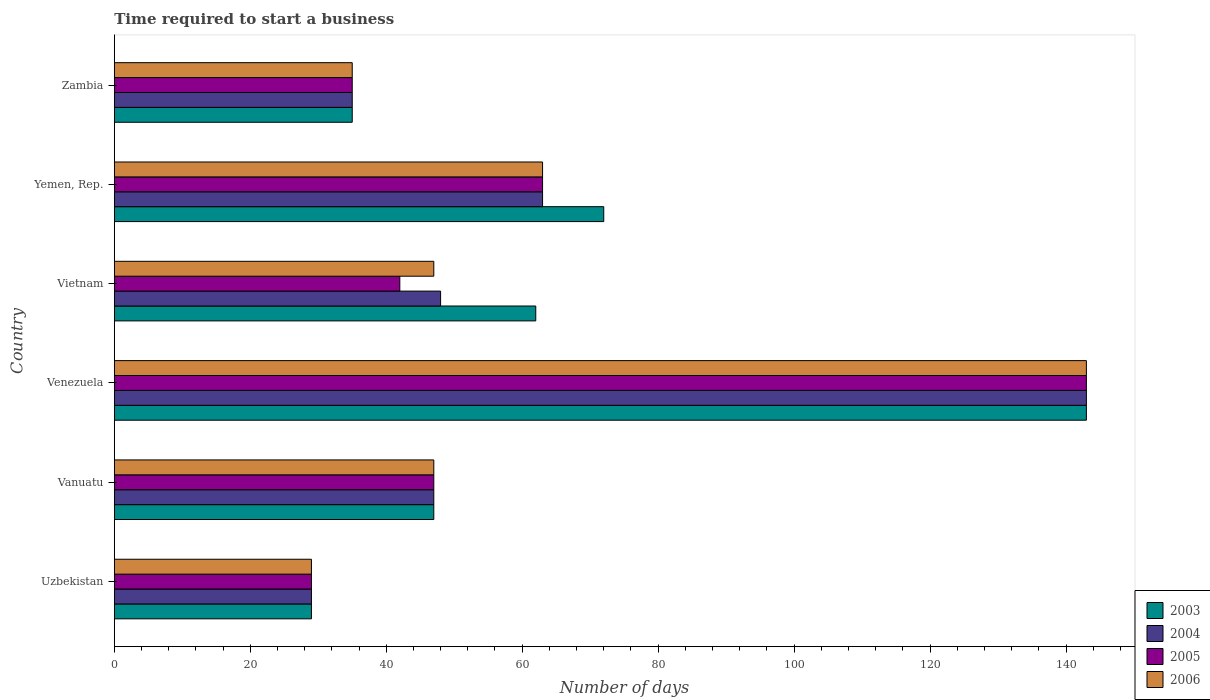How many groups of bars are there?
Make the answer very short. 6. Are the number of bars per tick equal to the number of legend labels?
Give a very brief answer. Yes. Are the number of bars on each tick of the Y-axis equal?
Your answer should be compact. Yes. What is the label of the 5th group of bars from the top?
Offer a terse response. Vanuatu. In how many cases, is the number of bars for a given country not equal to the number of legend labels?
Your answer should be compact. 0. What is the number of days required to start a business in 2004 in Uzbekistan?
Your answer should be very brief. 29. Across all countries, what is the maximum number of days required to start a business in 2004?
Make the answer very short. 143. In which country was the number of days required to start a business in 2003 maximum?
Your answer should be very brief. Venezuela. In which country was the number of days required to start a business in 2003 minimum?
Your answer should be very brief. Uzbekistan. What is the total number of days required to start a business in 2004 in the graph?
Your answer should be very brief. 365. What is the difference between the number of days required to start a business in 2003 in Vanuatu and that in Zambia?
Your answer should be compact. 12. What is the difference between the number of days required to start a business in 2004 in Yemen, Rep. and the number of days required to start a business in 2005 in Venezuela?
Provide a succinct answer. -80. What is the average number of days required to start a business in 2005 per country?
Provide a succinct answer. 59.83. What is the difference between the number of days required to start a business in 2003 and number of days required to start a business in 2006 in Zambia?
Provide a succinct answer. 0. What is the ratio of the number of days required to start a business in 2004 in Uzbekistan to that in Vietnam?
Offer a very short reply. 0.6. Is the number of days required to start a business in 2004 in Venezuela less than that in Zambia?
Provide a succinct answer. No. What is the difference between the highest and the second highest number of days required to start a business in 2004?
Offer a very short reply. 80. What is the difference between the highest and the lowest number of days required to start a business in 2005?
Provide a succinct answer. 114. In how many countries, is the number of days required to start a business in 2004 greater than the average number of days required to start a business in 2004 taken over all countries?
Offer a terse response. 2. Is it the case that in every country, the sum of the number of days required to start a business in 2005 and number of days required to start a business in 2006 is greater than the sum of number of days required to start a business in 2004 and number of days required to start a business in 2003?
Provide a succinct answer. No. What does the 1st bar from the top in Vanuatu represents?
Ensure brevity in your answer.  2006. How many bars are there?
Your answer should be compact. 24. How many countries are there in the graph?
Your answer should be compact. 6. Are the values on the major ticks of X-axis written in scientific E-notation?
Your answer should be very brief. No. Does the graph contain grids?
Offer a terse response. No. What is the title of the graph?
Provide a succinct answer. Time required to start a business. What is the label or title of the X-axis?
Offer a terse response. Number of days. What is the label or title of the Y-axis?
Provide a short and direct response. Country. What is the Number of days in 2004 in Vanuatu?
Your response must be concise. 47. What is the Number of days in 2005 in Vanuatu?
Offer a very short reply. 47. What is the Number of days of 2003 in Venezuela?
Provide a succinct answer. 143. What is the Number of days of 2004 in Venezuela?
Make the answer very short. 143. What is the Number of days in 2005 in Venezuela?
Provide a short and direct response. 143. What is the Number of days of 2006 in Venezuela?
Your answer should be very brief. 143. What is the Number of days in 2003 in Vietnam?
Your response must be concise. 62. What is the Number of days of 2004 in Vietnam?
Ensure brevity in your answer.  48. What is the Number of days of 2005 in Vietnam?
Provide a succinct answer. 42. What is the Number of days in 2003 in Yemen, Rep.?
Ensure brevity in your answer.  72. What is the Number of days of 2004 in Yemen, Rep.?
Your response must be concise. 63. What is the Number of days in 2005 in Yemen, Rep.?
Your answer should be compact. 63. What is the Number of days in 2006 in Yemen, Rep.?
Offer a terse response. 63. What is the Number of days of 2004 in Zambia?
Offer a terse response. 35. Across all countries, what is the maximum Number of days of 2003?
Your answer should be compact. 143. Across all countries, what is the maximum Number of days in 2004?
Your response must be concise. 143. Across all countries, what is the maximum Number of days of 2005?
Provide a short and direct response. 143. Across all countries, what is the maximum Number of days of 2006?
Ensure brevity in your answer.  143. Across all countries, what is the minimum Number of days of 2003?
Your answer should be compact. 29. What is the total Number of days in 2003 in the graph?
Offer a terse response. 388. What is the total Number of days in 2004 in the graph?
Ensure brevity in your answer.  365. What is the total Number of days in 2005 in the graph?
Keep it short and to the point. 359. What is the total Number of days in 2006 in the graph?
Provide a succinct answer. 364. What is the difference between the Number of days of 2003 in Uzbekistan and that in Vanuatu?
Provide a short and direct response. -18. What is the difference between the Number of days in 2004 in Uzbekistan and that in Vanuatu?
Provide a short and direct response. -18. What is the difference between the Number of days of 2005 in Uzbekistan and that in Vanuatu?
Provide a succinct answer. -18. What is the difference between the Number of days of 2006 in Uzbekistan and that in Vanuatu?
Give a very brief answer. -18. What is the difference between the Number of days of 2003 in Uzbekistan and that in Venezuela?
Keep it short and to the point. -114. What is the difference between the Number of days of 2004 in Uzbekistan and that in Venezuela?
Ensure brevity in your answer.  -114. What is the difference between the Number of days of 2005 in Uzbekistan and that in Venezuela?
Offer a terse response. -114. What is the difference between the Number of days of 2006 in Uzbekistan and that in Venezuela?
Offer a very short reply. -114. What is the difference between the Number of days of 2003 in Uzbekistan and that in Vietnam?
Your response must be concise. -33. What is the difference between the Number of days in 2005 in Uzbekistan and that in Vietnam?
Your answer should be compact. -13. What is the difference between the Number of days of 2006 in Uzbekistan and that in Vietnam?
Make the answer very short. -18. What is the difference between the Number of days of 2003 in Uzbekistan and that in Yemen, Rep.?
Make the answer very short. -43. What is the difference between the Number of days of 2004 in Uzbekistan and that in Yemen, Rep.?
Give a very brief answer. -34. What is the difference between the Number of days of 2005 in Uzbekistan and that in Yemen, Rep.?
Ensure brevity in your answer.  -34. What is the difference between the Number of days of 2006 in Uzbekistan and that in Yemen, Rep.?
Ensure brevity in your answer.  -34. What is the difference between the Number of days of 2003 in Uzbekistan and that in Zambia?
Your response must be concise. -6. What is the difference between the Number of days in 2005 in Uzbekistan and that in Zambia?
Your answer should be compact. -6. What is the difference between the Number of days in 2006 in Uzbekistan and that in Zambia?
Your response must be concise. -6. What is the difference between the Number of days in 2003 in Vanuatu and that in Venezuela?
Your response must be concise. -96. What is the difference between the Number of days in 2004 in Vanuatu and that in Venezuela?
Keep it short and to the point. -96. What is the difference between the Number of days in 2005 in Vanuatu and that in Venezuela?
Give a very brief answer. -96. What is the difference between the Number of days in 2006 in Vanuatu and that in Venezuela?
Provide a short and direct response. -96. What is the difference between the Number of days in 2003 in Vanuatu and that in Vietnam?
Your answer should be very brief. -15. What is the difference between the Number of days of 2004 in Vanuatu and that in Vietnam?
Your answer should be compact. -1. What is the difference between the Number of days in 2005 in Vanuatu and that in Yemen, Rep.?
Keep it short and to the point. -16. What is the difference between the Number of days in 2006 in Vanuatu and that in Yemen, Rep.?
Make the answer very short. -16. What is the difference between the Number of days of 2005 in Vanuatu and that in Zambia?
Offer a very short reply. 12. What is the difference between the Number of days in 2006 in Vanuatu and that in Zambia?
Ensure brevity in your answer.  12. What is the difference between the Number of days of 2003 in Venezuela and that in Vietnam?
Offer a very short reply. 81. What is the difference between the Number of days of 2004 in Venezuela and that in Vietnam?
Provide a succinct answer. 95. What is the difference between the Number of days in 2005 in Venezuela and that in Vietnam?
Keep it short and to the point. 101. What is the difference between the Number of days of 2006 in Venezuela and that in Vietnam?
Make the answer very short. 96. What is the difference between the Number of days in 2005 in Venezuela and that in Yemen, Rep.?
Offer a very short reply. 80. What is the difference between the Number of days in 2006 in Venezuela and that in Yemen, Rep.?
Offer a terse response. 80. What is the difference between the Number of days of 2003 in Venezuela and that in Zambia?
Offer a terse response. 108. What is the difference between the Number of days of 2004 in Venezuela and that in Zambia?
Your answer should be compact. 108. What is the difference between the Number of days of 2005 in Venezuela and that in Zambia?
Your answer should be very brief. 108. What is the difference between the Number of days of 2006 in Venezuela and that in Zambia?
Your response must be concise. 108. What is the difference between the Number of days of 2004 in Vietnam and that in Zambia?
Your answer should be compact. 13. What is the difference between the Number of days in 2005 in Vietnam and that in Zambia?
Your response must be concise. 7. What is the difference between the Number of days of 2003 in Yemen, Rep. and that in Zambia?
Give a very brief answer. 37. What is the difference between the Number of days in 2004 in Yemen, Rep. and that in Zambia?
Provide a short and direct response. 28. What is the difference between the Number of days in 2005 in Yemen, Rep. and that in Zambia?
Ensure brevity in your answer.  28. What is the difference between the Number of days of 2006 in Yemen, Rep. and that in Zambia?
Keep it short and to the point. 28. What is the difference between the Number of days in 2004 in Uzbekistan and the Number of days in 2005 in Vanuatu?
Give a very brief answer. -18. What is the difference between the Number of days of 2003 in Uzbekistan and the Number of days of 2004 in Venezuela?
Your answer should be compact. -114. What is the difference between the Number of days in 2003 in Uzbekistan and the Number of days in 2005 in Venezuela?
Give a very brief answer. -114. What is the difference between the Number of days in 2003 in Uzbekistan and the Number of days in 2006 in Venezuela?
Keep it short and to the point. -114. What is the difference between the Number of days in 2004 in Uzbekistan and the Number of days in 2005 in Venezuela?
Give a very brief answer. -114. What is the difference between the Number of days of 2004 in Uzbekistan and the Number of days of 2006 in Venezuela?
Your answer should be very brief. -114. What is the difference between the Number of days of 2005 in Uzbekistan and the Number of days of 2006 in Venezuela?
Offer a very short reply. -114. What is the difference between the Number of days of 2003 in Uzbekistan and the Number of days of 2004 in Vietnam?
Your answer should be compact. -19. What is the difference between the Number of days of 2003 in Uzbekistan and the Number of days of 2004 in Yemen, Rep.?
Provide a short and direct response. -34. What is the difference between the Number of days of 2003 in Uzbekistan and the Number of days of 2005 in Yemen, Rep.?
Offer a terse response. -34. What is the difference between the Number of days in 2003 in Uzbekistan and the Number of days in 2006 in Yemen, Rep.?
Your answer should be very brief. -34. What is the difference between the Number of days in 2004 in Uzbekistan and the Number of days in 2005 in Yemen, Rep.?
Provide a succinct answer. -34. What is the difference between the Number of days in 2004 in Uzbekistan and the Number of days in 2006 in Yemen, Rep.?
Give a very brief answer. -34. What is the difference between the Number of days of 2005 in Uzbekistan and the Number of days of 2006 in Yemen, Rep.?
Your answer should be very brief. -34. What is the difference between the Number of days of 2003 in Uzbekistan and the Number of days of 2004 in Zambia?
Make the answer very short. -6. What is the difference between the Number of days of 2004 in Uzbekistan and the Number of days of 2006 in Zambia?
Offer a terse response. -6. What is the difference between the Number of days in 2005 in Uzbekistan and the Number of days in 2006 in Zambia?
Offer a terse response. -6. What is the difference between the Number of days in 2003 in Vanuatu and the Number of days in 2004 in Venezuela?
Offer a terse response. -96. What is the difference between the Number of days in 2003 in Vanuatu and the Number of days in 2005 in Venezuela?
Provide a succinct answer. -96. What is the difference between the Number of days in 2003 in Vanuatu and the Number of days in 2006 in Venezuela?
Make the answer very short. -96. What is the difference between the Number of days of 2004 in Vanuatu and the Number of days of 2005 in Venezuela?
Your answer should be very brief. -96. What is the difference between the Number of days in 2004 in Vanuatu and the Number of days in 2006 in Venezuela?
Your answer should be compact. -96. What is the difference between the Number of days in 2005 in Vanuatu and the Number of days in 2006 in Venezuela?
Your answer should be very brief. -96. What is the difference between the Number of days of 2005 in Vanuatu and the Number of days of 2006 in Vietnam?
Your response must be concise. 0. What is the difference between the Number of days of 2003 in Vanuatu and the Number of days of 2005 in Yemen, Rep.?
Ensure brevity in your answer.  -16. What is the difference between the Number of days in 2004 in Vanuatu and the Number of days in 2005 in Yemen, Rep.?
Provide a short and direct response. -16. What is the difference between the Number of days of 2004 in Vanuatu and the Number of days of 2006 in Yemen, Rep.?
Make the answer very short. -16. What is the difference between the Number of days in 2005 in Vanuatu and the Number of days in 2006 in Yemen, Rep.?
Provide a succinct answer. -16. What is the difference between the Number of days of 2003 in Vanuatu and the Number of days of 2004 in Zambia?
Provide a succinct answer. 12. What is the difference between the Number of days in 2003 in Vanuatu and the Number of days in 2005 in Zambia?
Offer a very short reply. 12. What is the difference between the Number of days in 2003 in Vanuatu and the Number of days in 2006 in Zambia?
Offer a terse response. 12. What is the difference between the Number of days of 2004 in Vanuatu and the Number of days of 2005 in Zambia?
Offer a very short reply. 12. What is the difference between the Number of days of 2003 in Venezuela and the Number of days of 2004 in Vietnam?
Provide a short and direct response. 95. What is the difference between the Number of days of 2003 in Venezuela and the Number of days of 2005 in Vietnam?
Keep it short and to the point. 101. What is the difference between the Number of days of 2003 in Venezuela and the Number of days of 2006 in Vietnam?
Offer a terse response. 96. What is the difference between the Number of days of 2004 in Venezuela and the Number of days of 2005 in Vietnam?
Offer a very short reply. 101. What is the difference between the Number of days in 2004 in Venezuela and the Number of days in 2006 in Vietnam?
Offer a terse response. 96. What is the difference between the Number of days in 2005 in Venezuela and the Number of days in 2006 in Vietnam?
Provide a short and direct response. 96. What is the difference between the Number of days of 2005 in Venezuela and the Number of days of 2006 in Yemen, Rep.?
Make the answer very short. 80. What is the difference between the Number of days of 2003 in Venezuela and the Number of days of 2004 in Zambia?
Provide a short and direct response. 108. What is the difference between the Number of days of 2003 in Venezuela and the Number of days of 2005 in Zambia?
Ensure brevity in your answer.  108. What is the difference between the Number of days of 2003 in Venezuela and the Number of days of 2006 in Zambia?
Your answer should be compact. 108. What is the difference between the Number of days of 2004 in Venezuela and the Number of days of 2005 in Zambia?
Offer a very short reply. 108. What is the difference between the Number of days of 2004 in Venezuela and the Number of days of 2006 in Zambia?
Provide a short and direct response. 108. What is the difference between the Number of days of 2005 in Venezuela and the Number of days of 2006 in Zambia?
Provide a short and direct response. 108. What is the difference between the Number of days of 2003 in Vietnam and the Number of days of 2004 in Yemen, Rep.?
Offer a terse response. -1. What is the difference between the Number of days of 2003 in Vietnam and the Number of days of 2006 in Yemen, Rep.?
Your answer should be very brief. -1. What is the difference between the Number of days in 2005 in Vietnam and the Number of days in 2006 in Yemen, Rep.?
Offer a terse response. -21. What is the difference between the Number of days in 2003 in Vietnam and the Number of days in 2004 in Zambia?
Make the answer very short. 27. What is the difference between the Number of days in 2003 in Vietnam and the Number of days in 2006 in Zambia?
Offer a very short reply. 27. What is the difference between the Number of days in 2004 in Vietnam and the Number of days in 2005 in Zambia?
Your answer should be very brief. 13. What is the difference between the Number of days of 2004 in Vietnam and the Number of days of 2006 in Zambia?
Provide a succinct answer. 13. What is the difference between the Number of days of 2003 in Yemen, Rep. and the Number of days of 2005 in Zambia?
Offer a terse response. 37. What is the difference between the Number of days of 2005 in Yemen, Rep. and the Number of days of 2006 in Zambia?
Provide a short and direct response. 28. What is the average Number of days of 2003 per country?
Make the answer very short. 64.67. What is the average Number of days in 2004 per country?
Your response must be concise. 60.83. What is the average Number of days in 2005 per country?
Keep it short and to the point. 59.83. What is the average Number of days in 2006 per country?
Provide a short and direct response. 60.67. What is the difference between the Number of days of 2003 and Number of days of 2004 in Uzbekistan?
Give a very brief answer. 0. What is the difference between the Number of days of 2003 and Number of days of 2005 in Uzbekistan?
Offer a terse response. 0. What is the difference between the Number of days in 2003 and Number of days in 2006 in Uzbekistan?
Offer a very short reply. 0. What is the difference between the Number of days in 2004 and Number of days in 2005 in Uzbekistan?
Provide a succinct answer. 0. What is the difference between the Number of days of 2004 and Number of days of 2006 in Uzbekistan?
Provide a short and direct response. 0. What is the difference between the Number of days in 2005 and Number of days in 2006 in Uzbekistan?
Make the answer very short. 0. What is the difference between the Number of days in 2003 and Number of days in 2005 in Vanuatu?
Your answer should be compact. 0. What is the difference between the Number of days in 2003 and Number of days in 2006 in Vanuatu?
Your answer should be compact. 0. What is the difference between the Number of days in 2004 and Number of days in 2005 in Vanuatu?
Keep it short and to the point. 0. What is the difference between the Number of days of 2003 and Number of days of 2006 in Venezuela?
Your response must be concise. 0. What is the difference between the Number of days of 2004 and Number of days of 2005 in Venezuela?
Offer a terse response. 0. What is the difference between the Number of days of 2003 and Number of days of 2004 in Vietnam?
Make the answer very short. 14. What is the difference between the Number of days in 2003 and Number of days in 2006 in Vietnam?
Keep it short and to the point. 15. What is the difference between the Number of days in 2004 and Number of days in 2005 in Vietnam?
Provide a short and direct response. 6. What is the difference between the Number of days of 2005 and Number of days of 2006 in Vietnam?
Ensure brevity in your answer.  -5. What is the difference between the Number of days in 2003 and Number of days in 2004 in Yemen, Rep.?
Give a very brief answer. 9. What is the difference between the Number of days in 2003 and Number of days in 2005 in Yemen, Rep.?
Your answer should be compact. 9. What is the difference between the Number of days in 2003 and Number of days in 2006 in Yemen, Rep.?
Ensure brevity in your answer.  9. What is the difference between the Number of days in 2004 and Number of days in 2005 in Yemen, Rep.?
Provide a short and direct response. 0. What is the difference between the Number of days of 2005 and Number of days of 2006 in Yemen, Rep.?
Provide a succinct answer. 0. What is the difference between the Number of days of 2003 and Number of days of 2005 in Zambia?
Ensure brevity in your answer.  0. What is the difference between the Number of days of 2003 and Number of days of 2006 in Zambia?
Give a very brief answer. 0. What is the difference between the Number of days in 2004 and Number of days in 2005 in Zambia?
Your answer should be very brief. 0. What is the difference between the Number of days in 2005 and Number of days in 2006 in Zambia?
Offer a terse response. 0. What is the ratio of the Number of days of 2003 in Uzbekistan to that in Vanuatu?
Provide a succinct answer. 0.62. What is the ratio of the Number of days in 2004 in Uzbekistan to that in Vanuatu?
Provide a short and direct response. 0.62. What is the ratio of the Number of days of 2005 in Uzbekistan to that in Vanuatu?
Your response must be concise. 0.62. What is the ratio of the Number of days of 2006 in Uzbekistan to that in Vanuatu?
Make the answer very short. 0.62. What is the ratio of the Number of days of 2003 in Uzbekistan to that in Venezuela?
Ensure brevity in your answer.  0.2. What is the ratio of the Number of days of 2004 in Uzbekistan to that in Venezuela?
Ensure brevity in your answer.  0.2. What is the ratio of the Number of days in 2005 in Uzbekistan to that in Venezuela?
Provide a succinct answer. 0.2. What is the ratio of the Number of days of 2006 in Uzbekistan to that in Venezuela?
Offer a terse response. 0.2. What is the ratio of the Number of days of 2003 in Uzbekistan to that in Vietnam?
Make the answer very short. 0.47. What is the ratio of the Number of days of 2004 in Uzbekistan to that in Vietnam?
Provide a succinct answer. 0.6. What is the ratio of the Number of days in 2005 in Uzbekistan to that in Vietnam?
Offer a very short reply. 0.69. What is the ratio of the Number of days in 2006 in Uzbekistan to that in Vietnam?
Your response must be concise. 0.62. What is the ratio of the Number of days of 2003 in Uzbekistan to that in Yemen, Rep.?
Ensure brevity in your answer.  0.4. What is the ratio of the Number of days of 2004 in Uzbekistan to that in Yemen, Rep.?
Give a very brief answer. 0.46. What is the ratio of the Number of days of 2005 in Uzbekistan to that in Yemen, Rep.?
Offer a very short reply. 0.46. What is the ratio of the Number of days of 2006 in Uzbekistan to that in Yemen, Rep.?
Ensure brevity in your answer.  0.46. What is the ratio of the Number of days of 2003 in Uzbekistan to that in Zambia?
Provide a short and direct response. 0.83. What is the ratio of the Number of days in 2004 in Uzbekistan to that in Zambia?
Offer a very short reply. 0.83. What is the ratio of the Number of days in 2005 in Uzbekistan to that in Zambia?
Keep it short and to the point. 0.83. What is the ratio of the Number of days in 2006 in Uzbekistan to that in Zambia?
Your answer should be compact. 0.83. What is the ratio of the Number of days in 2003 in Vanuatu to that in Venezuela?
Offer a very short reply. 0.33. What is the ratio of the Number of days in 2004 in Vanuatu to that in Venezuela?
Offer a terse response. 0.33. What is the ratio of the Number of days of 2005 in Vanuatu to that in Venezuela?
Provide a succinct answer. 0.33. What is the ratio of the Number of days of 2006 in Vanuatu to that in Venezuela?
Your response must be concise. 0.33. What is the ratio of the Number of days in 2003 in Vanuatu to that in Vietnam?
Make the answer very short. 0.76. What is the ratio of the Number of days in 2004 in Vanuatu to that in Vietnam?
Provide a short and direct response. 0.98. What is the ratio of the Number of days of 2005 in Vanuatu to that in Vietnam?
Your answer should be compact. 1.12. What is the ratio of the Number of days of 2006 in Vanuatu to that in Vietnam?
Provide a succinct answer. 1. What is the ratio of the Number of days in 2003 in Vanuatu to that in Yemen, Rep.?
Keep it short and to the point. 0.65. What is the ratio of the Number of days of 2004 in Vanuatu to that in Yemen, Rep.?
Your response must be concise. 0.75. What is the ratio of the Number of days of 2005 in Vanuatu to that in Yemen, Rep.?
Your answer should be very brief. 0.75. What is the ratio of the Number of days in 2006 in Vanuatu to that in Yemen, Rep.?
Give a very brief answer. 0.75. What is the ratio of the Number of days of 2003 in Vanuatu to that in Zambia?
Your response must be concise. 1.34. What is the ratio of the Number of days of 2004 in Vanuatu to that in Zambia?
Give a very brief answer. 1.34. What is the ratio of the Number of days of 2005 in Vanuatu to that in Zambia?
Offer a terse response. 1.34. What is the ratio of the Number of days in 2006 in Vanuatu to that in Zambia?
Offer a terse response. 1.34. What is the ratio of the Number of days of 2003 in Venezuela to that in Vietnam?
Offer a terse response. 2.31. What is the ratio of the Number of days in 2004 in Venezuela to that in Vietnam?
Your response must be concise. 2.98. What is the ratio of the Number of days of 2005 in Venezuela to that in Vietnam?
Your answer should be very brief. 3.4. What is the ratio of the Number of days of 2006 in Venezuela to that in Vietnam?
Ensure brevity in your answer.  3.04. What is the ratio of the Number of days in 2003 in Venezuela to that in Yemen, Rep.?
Ensure brevity in your answer.  1.99. What is the ratio of the Number of days of 2004 in Venezuela to that in Yemen, Rep.?
Provide a succinct answer. 2.27. What is the ratio of the Number of days of 2005 in Venezuela to that in Yemen, Rep.?
Give a very brief answer. 2.27. What is the ratio of the Number of days of 2006 in Venezuela to that in Yemen, Rep.?
Your answer should be very brief. 2.27. What is the ratio of the Number of days in 2003 in Venezuela to that in Zambia?
Your response must be concise. 4.09. What is the ratio of the Number of days of 2004 in Venezuela to that in Zambia?
Provide a short and direct response. 4.09. What is the ratio of the Number of days in 2005 in Venezuela to that in Zambia?
Offer a very short reply. 4.09. What is the ratio of the Number of days in 2006 in Venezuela to that in Zambia?
Give a very brief answer. 4.09. What is the ratio of the Number of days in 2003 in Vietnam to that in Yemen, Rep.?
Offer a very short reply. 0.86. What is the ratio of the Number of days in 2004 in Vietnam to that in Yemen, Rep.?
Your response must be concise. 0.76. What is the ratio of the Number of days in 2006 in Vietnam to that in Yemen, Rep.?
Keep it short and to the point. 0.75. What is the ratio of the Number of days of 2003 in Vietnam to that in Zambia?
Your response must be concise. 1.77. What is the ratio of the Number of days in 2004 in Vietnam to that in Zambia?
Your answer should be very brief. 1.37. What is the ratio of the Number of days in 2005 in Vietnam to that in Zambia?
Provide a short and direct response. 1.2. What is the ratio of the Number of days in 2006 in Vietnam to that in Zambia?
Provide a short and direct response. 1.34. What is the ratio of the Number of days of 2003 in Yemen, Rep. to that in Zambia?
Provide a succinct answer. 2.06. What is the ratio of the Number of days in 2004 in Yemen, Rep. to that in Zambia?
Offer a terse response. 1.8. What is the ratio of the Number of days in 2005 in Yemen, Rep. to that in Zambia?
Give a very brief answer. 1.8. What is the ratio of the Number of days in 2006 in Yemen, Rep. to that in Zambia?
Provide a short and direct response. 1.8. What is the difference between the highest and the second highest Number of days in 2004?
Keep it short and to the point. 80. What is the difference between the highest and the second highest Number of days in 2005?
Make the answer very short. 80. What is the difference between the highest and the lowest Number of days of 2003?
Ensure brevity in your answer.  114. What is the difference between the highest and the lowest Number of days of 2004?
Your response must be concise. 114. What is the difference between the highest and the lowest Number of days of 2005?
Offer a very short reply. 114. What is the difference between the highest and the lowest Number of days of 2006?
Ensure brevity in your answer.  114. 